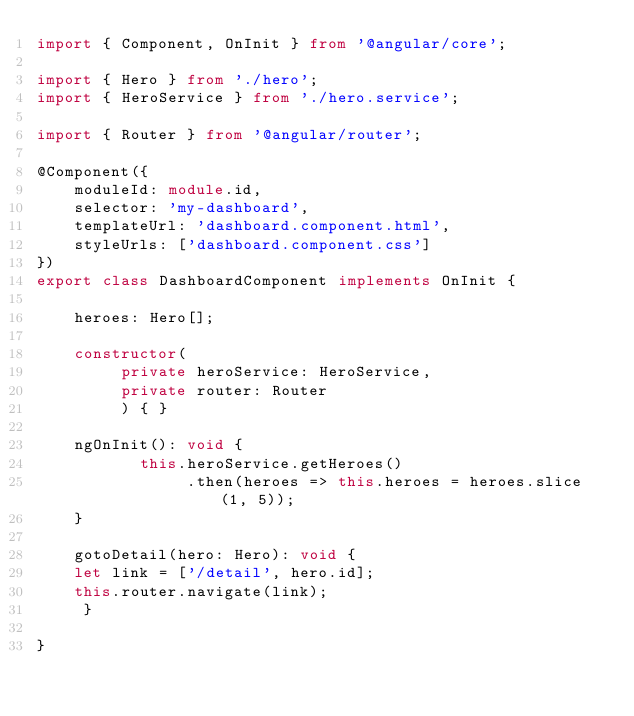<code> <loc_0><loc_0><loc_500><loc_500><_TypeScript_>import { Component, OnInit } from '@angular/core';

import { Hero } from './hero';
import { HeroService } from './hero.service';

import { Router } from '@angular/router';

@Component({
    moduleId: module.id,
    selector: 'my-dashboard',
    templateUrl: 'dashboard.component.html',
    styleUrls: ['dashboard.component.css']
})
export class DashboardComponent implements OnInit {

    heroes: Hero[];

    constructor(
         private heroService: HeroService,
         private router: Router
         ) { }

    ngOnInit(): void {
           this.heroService.getHeroes()
                .then(heroes => this.heroes = heroes.slice(1, 5));
    }

    gotoDetail(hero: Hero): void {
    let link = ['/detail', hero.id];
    this.router.navigate(link);
     }

}</code> 